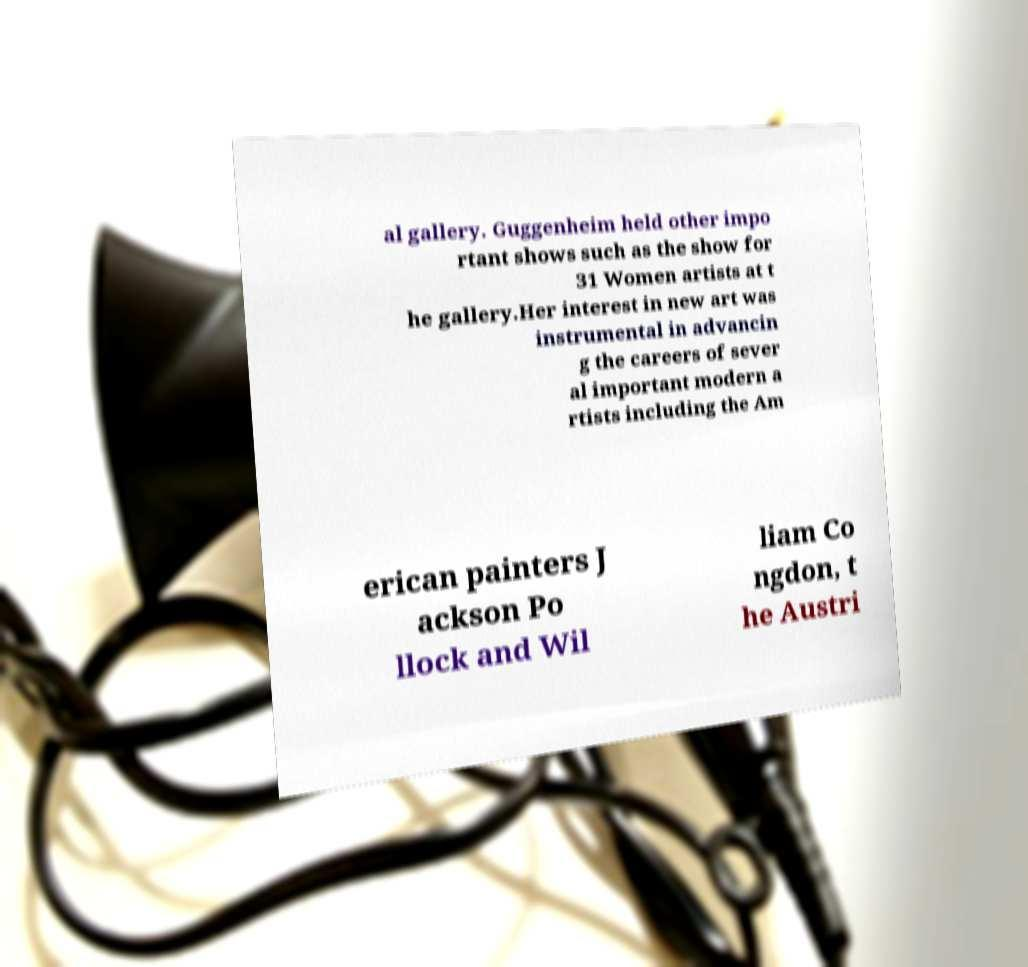What messages or text are displayed in this image? I need them in a readable, typed format. al gallery. Guggenheim held other impo rtant shows such as the show for 31 Women artists at t he gallery.Her interest in new art was instrumental in advancin g the careers of sever al important modern a rtists including the Am erican painters J ackson Po llock and Wil liam Co ngdon, t he Austri 